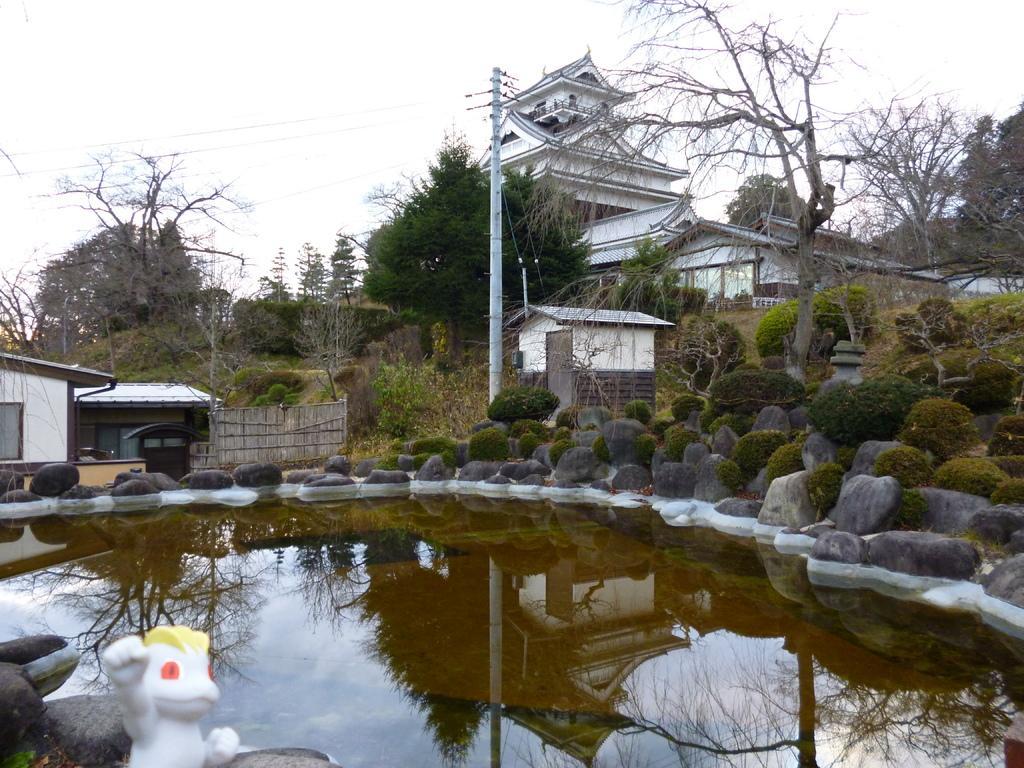Could you give a brief overview of what you see in this image? In this picture we can see water, stones, trees, buildings, pole and in the background we can see the sky. 